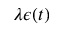Convert formula to latex. <formula><loc_0><loc_0><loc_500><loc_500>\lambda \epsilon ( t )</formula> 